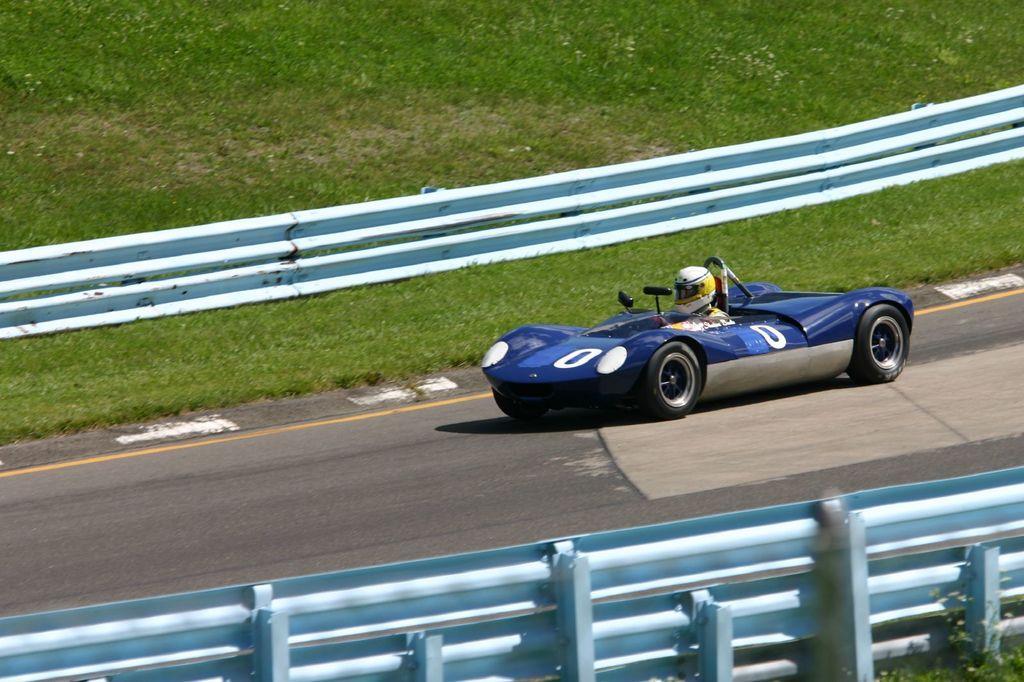Describe this image in one or two sentences. In the foreground of this picture, there is a sports car moving on the road to which railing present on both the sides and we can also see the grass. 